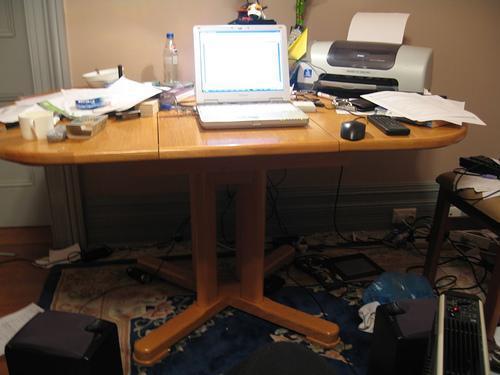How many water bottles are there?
Give a very brief answer. 1. How many monitor is there?
Give a very brief answer. 1. How many computers are shown?
Give a very brief answer. 1. How many dining tables are there?
Give a very brief answer. 1. How many people are shown?
Give a very brief answer. 0. 